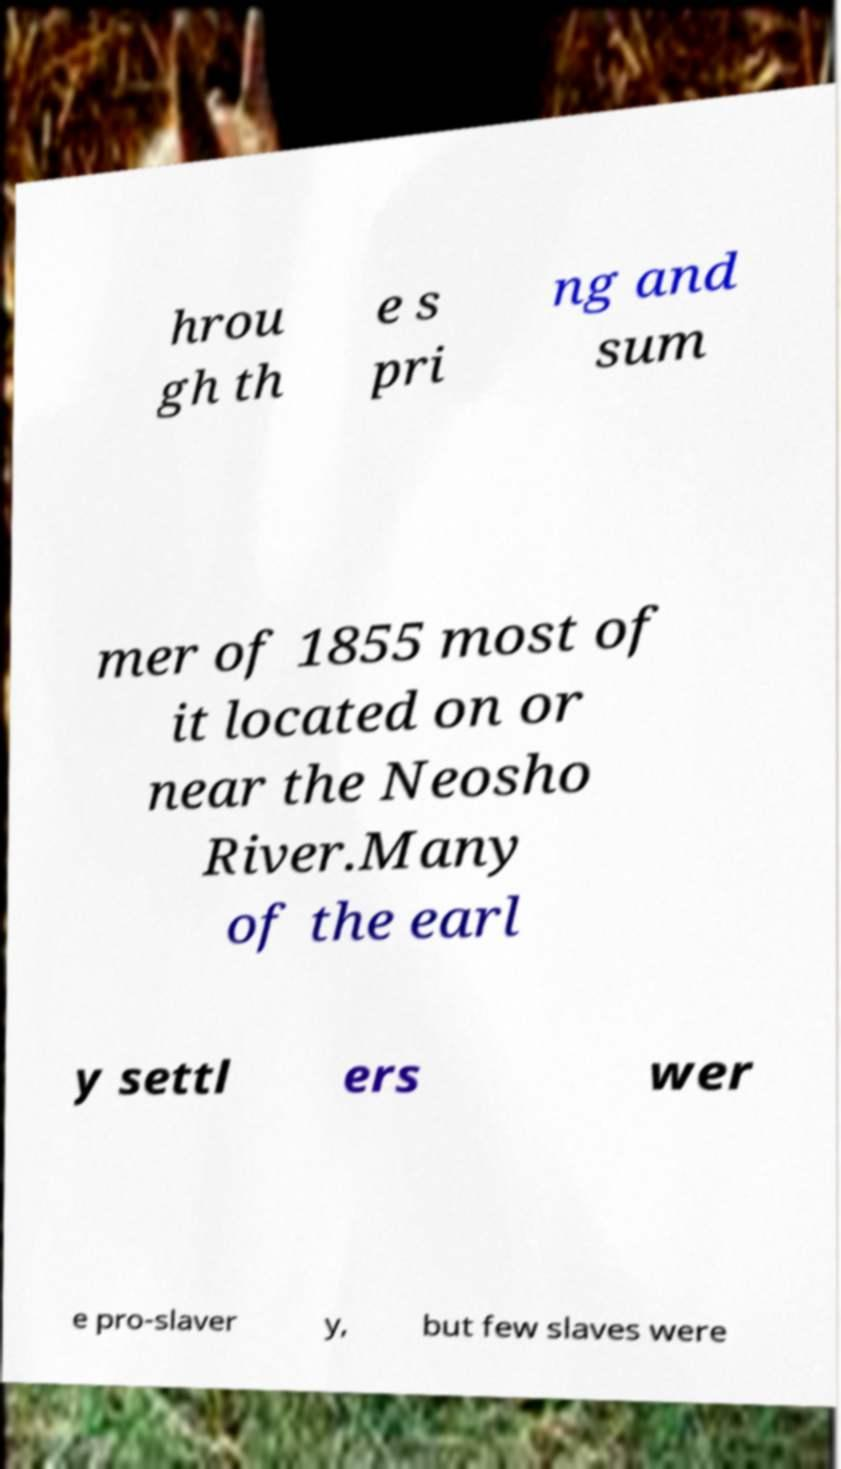Please read and relay the text visible in this image. What does it say? hrou gh th e s pri ng and sum mer of 1855 most of it located on or near the Neosho River.Many of the earl y settl ers wer e pro-slaver y, but few slaves were 